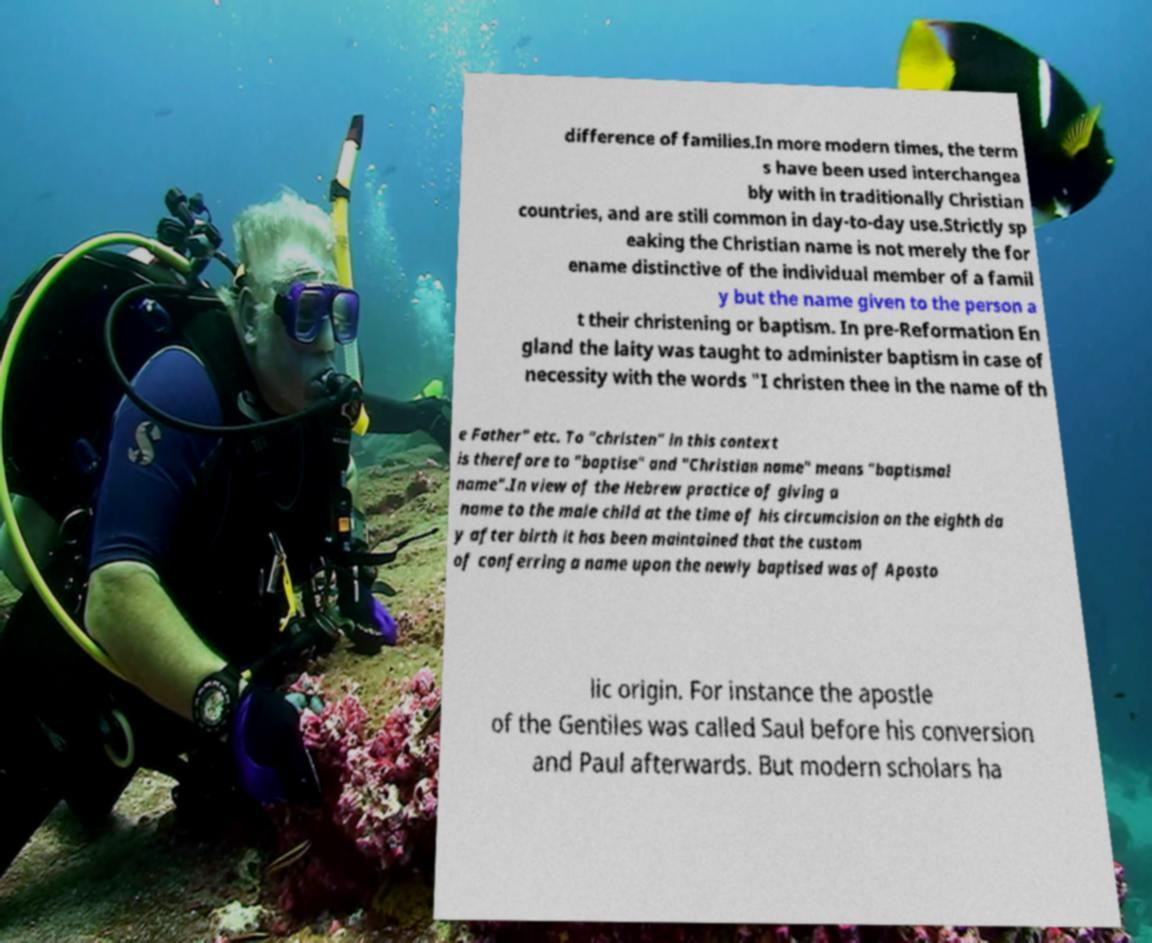Could you assist in decoding the text presented in this image and type it out clearly? difference of families.In more modern times, the term s have been used interchangea bly with in traditionally Christian countries, and are still common in day-to-day use.Strictly sp eaking the Christian name is not merely the for ename distinctive of the individual member of a famil y but the name given to the person a t their christening or baptism. In pre-Reformation En gland the laity was taught to administer baptism in case of necessity with the words "I christen thee in the name of th e Father" etc. To "christen" in this context is therefore to "baptise" and "Christian name" means "baptismal name".In view of the Hebrew practice of giving a name to the male child at the time of his circumcision on the eighth da y after birth it has been maintained that the custom of conferring a name upon the newly baptised was of Aposto lic origin. For instance the apostle of the Gentiles was called Saul before his conversion and Paul afterwards. But modern scholars ha 